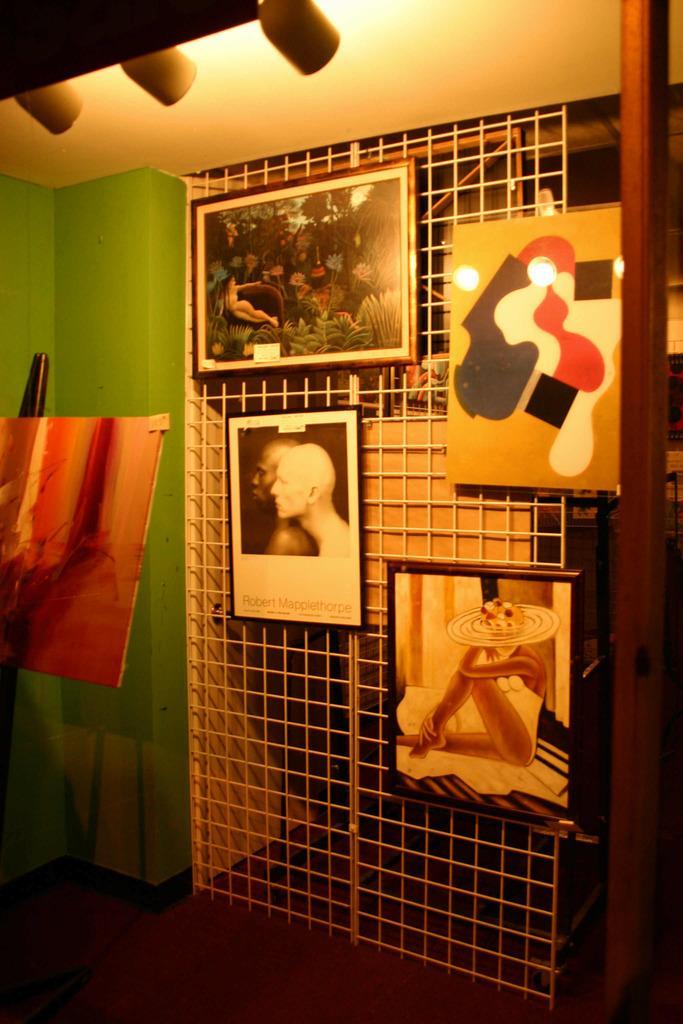In one or two sentences, can you explain what this image depicts? In this picture, we see a white color grill door on which photo frames are placed. Beside that, we see a green wall on which photo frame is placed. At the top of the picture, we see the ceiling of the room. This picture is clicked inside the room. 